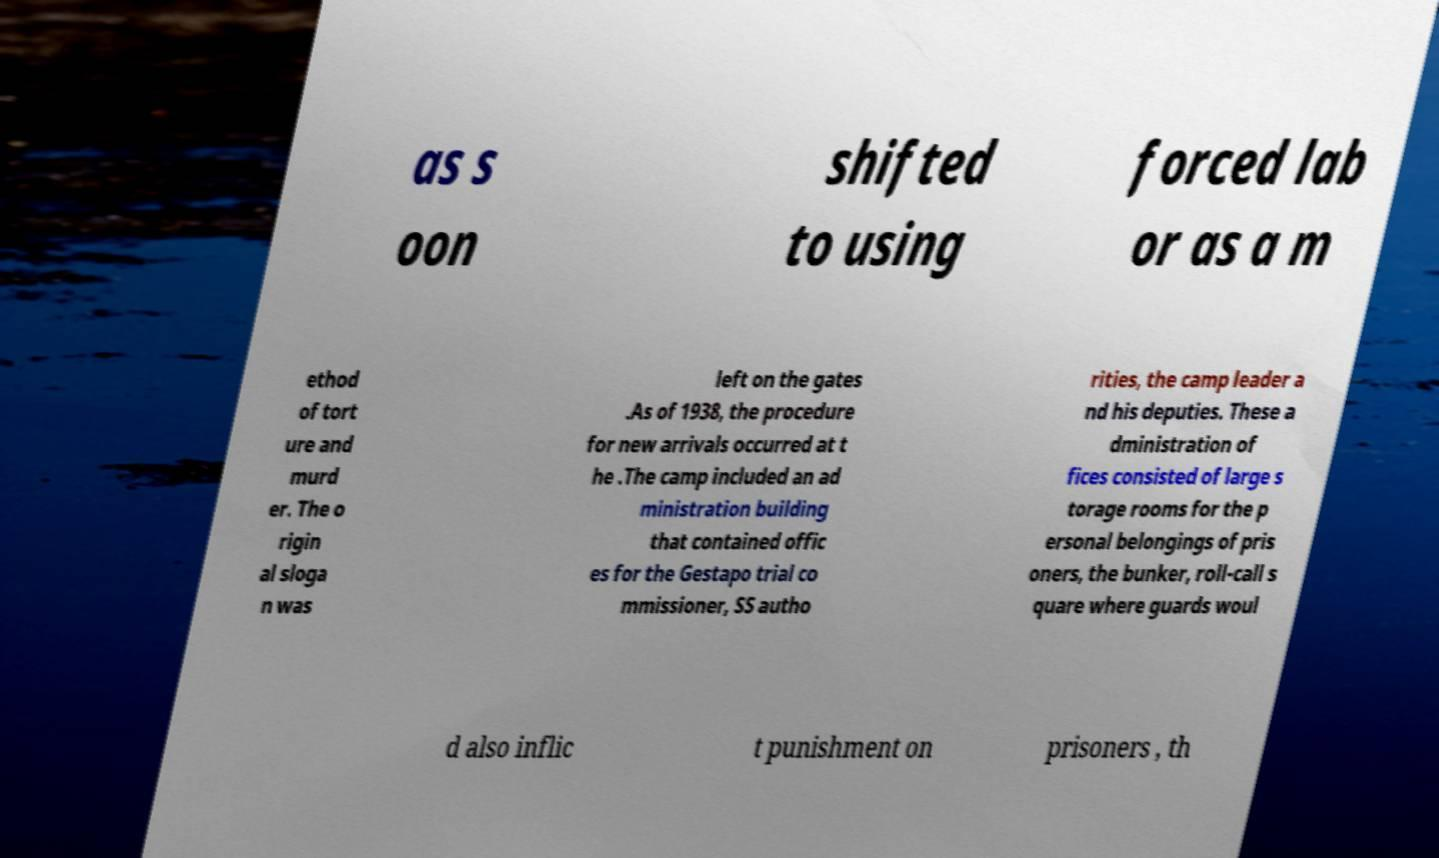What messages or text are displayed in this image? I need them in a readable, typed format. as s oon shifted to using forced lab or as a m ethod of tort ure and murd er. The o rigin al sloga n was left on the gates .As of 1938, the procedure for new arrivals occurred at t he .The camp included an ad ministration building that contained offic es for the Gestapo trial co mmissioner, SS autho rities, the camp leader a nd his deputies. These a dministration of fices consisted of large s torage rooms for the p ersonal belongings of pris oners, the bunker, roll-call s quare where guards woul d also inflic t punishment on prisoners , th 